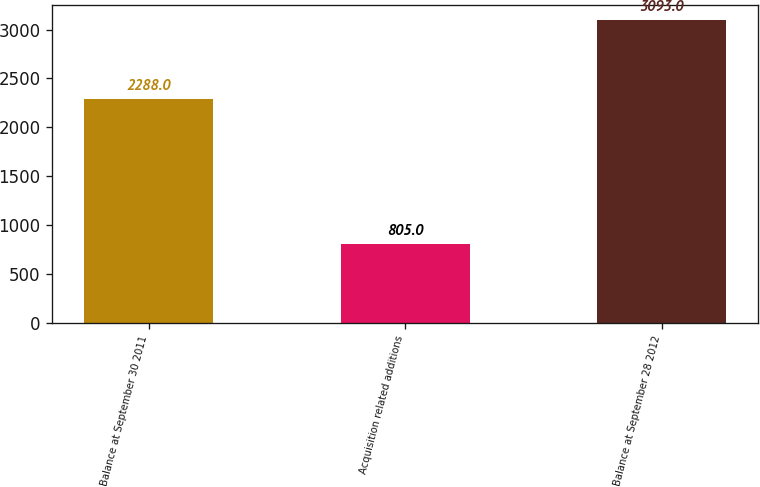<chart> <loc_0><loc_0><loc_500><loc_500><bar_chart><fcel>Balance at September 30 2011<fcel>Acquisition related additions<fcel>Balance at September 28 2012<nl><fcel>2288<fcel>805<fcel>3093<nl></chart> 